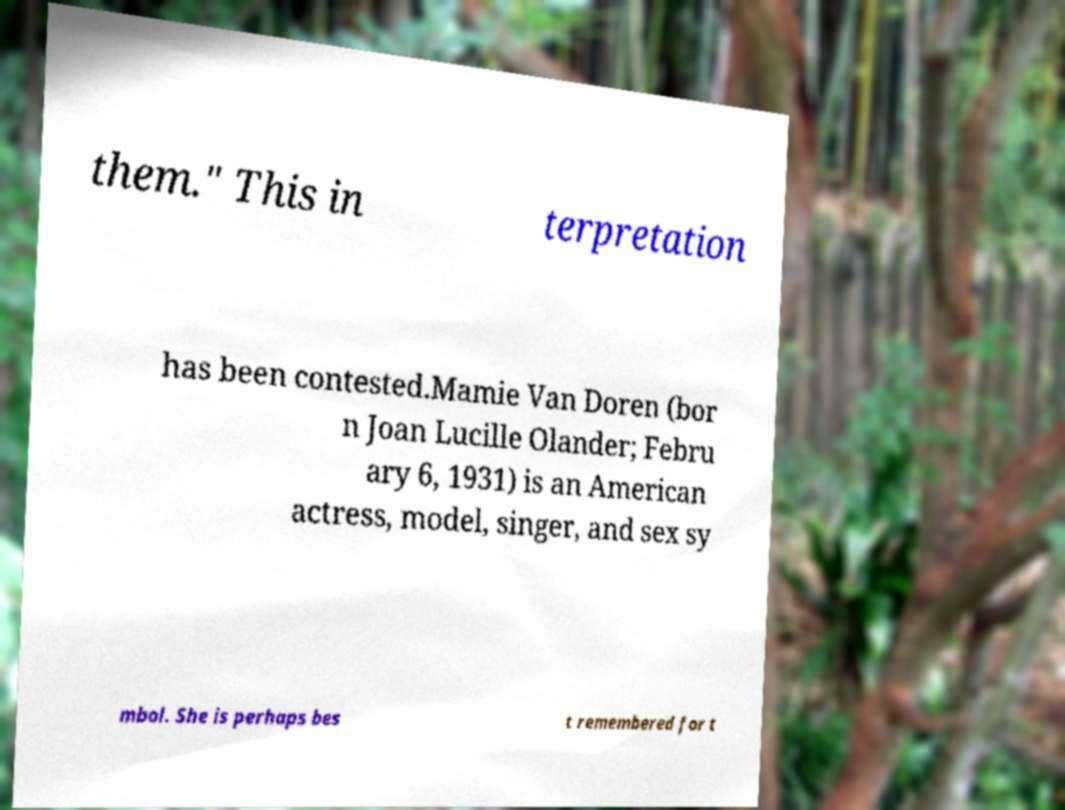Please read and relay the text visible in this image. What does it say? them." This in terpretation has been contested.Mamie Van Doren (bor n Joan Lucille Olander; Febru ary 6, 1931) is an American actress, model, singer, and sex sy mbol. She is perhaps bes t remembered for t 